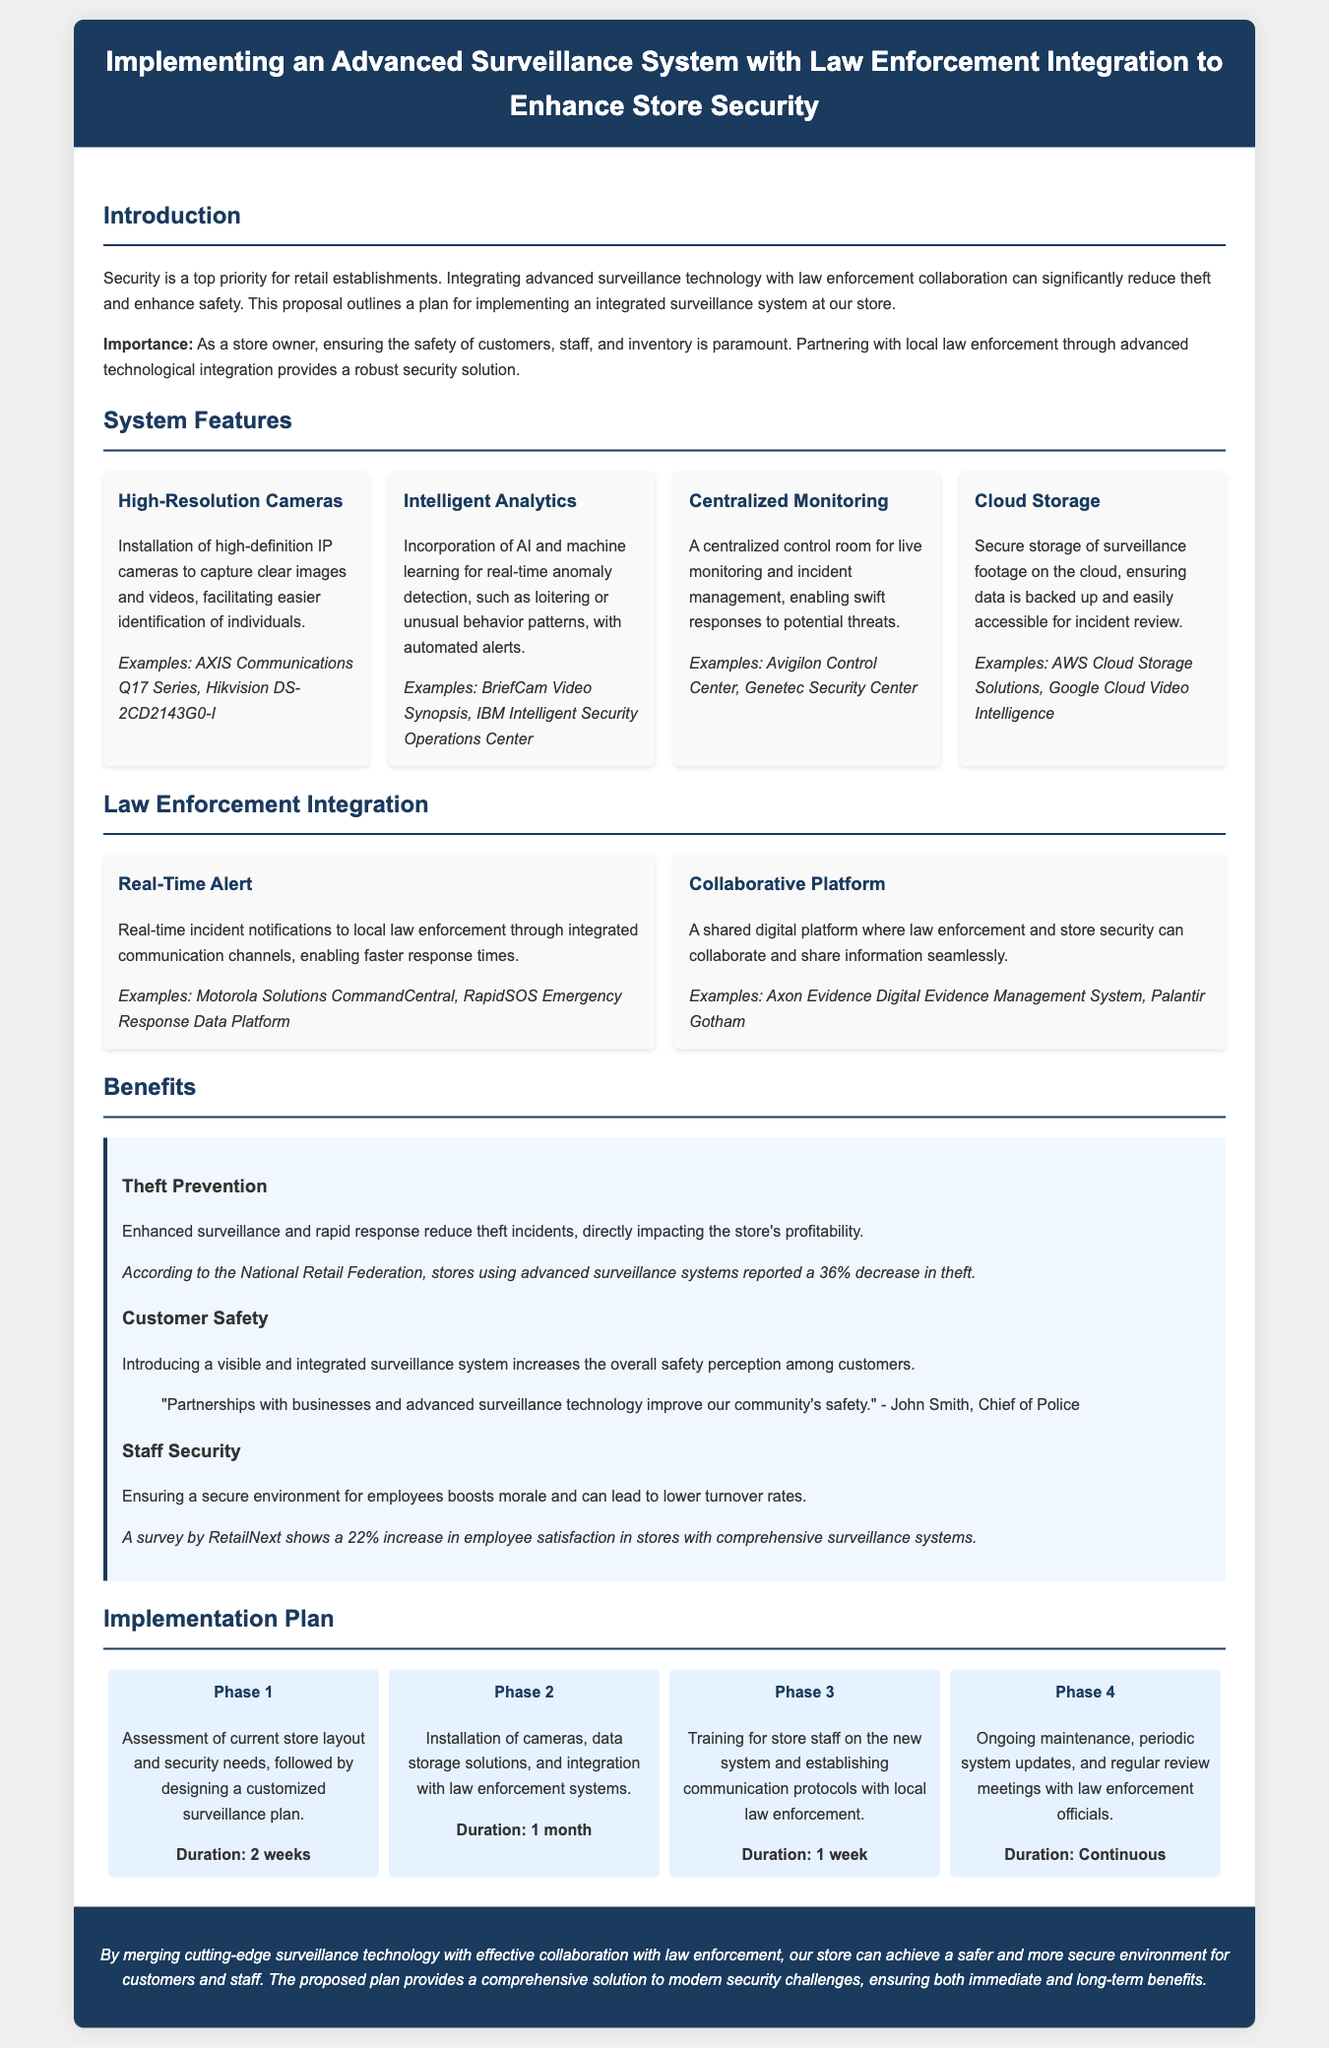What is the title of the proposal? The title is located in the header section of the document, stating the purpose of the proposal.
Answer: Implementing an Advanced Surveillance System with Law Enforcement Integration to Enhance Store Security What is the first phase of the implementation plan? The first phase is detailed in the implementation section, outlining the initial steps of the project.
Answer: Assessment of current store layout and security needs How many features are listed under System Features? The document presents four distinct features related to the advanced surveillance system.
Answer: 4 What is the duration of Phase 2 in the implementation plan? Each phase's duration is specified in the implementation timeline section of the document.
Answer: 1 month According to the National Retail Federation, what percentage decrease in theft was reported by stores using advanced surveillance systems? This information is mentioned in the benefits section, providing statistical support for the proposal.
Answer: 36% What is the main purpose of integrating with law enforcement? The reasoning for integration is explained under the Law Enforcement Integration section, emphasizing the goal of improving security.
Answer: Faster response times What type of technology is mentioned for real-time anomaly detection? The document specifies the technology incorporated in the surveillance system for this purpose.
Answer: AI and machine learning What is the color of the header background? The header background color is indicated by the styling in the document.
Answer: Dark blue What is the quote related to customer safety? The document includes a quote from a police official in the benefits section, reflecting the impact of the proposal.
Answer: "Partnerships with businesses and advanced surveillance technology improve our community's safety." - John Smith, Chief of Police 